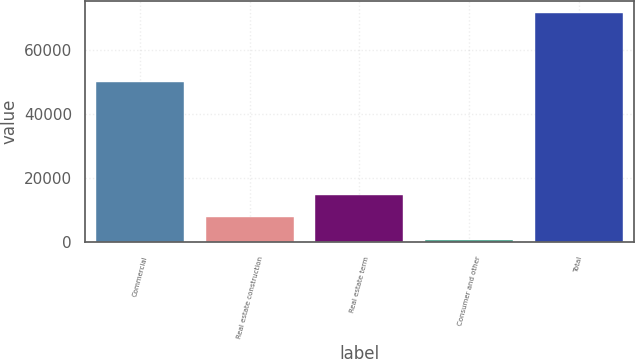Convert chart. <chart><loc_0><loc_0><loc_500><loc_500><bar_chart><fcel>Commercial<fcel>Real estate construction<fcel>Real estate term<fcel>Consumer and other<fcel>Total<nl><fcel>49985<fcel>7861.3<fcel>14965.6<fcel>757<fcel>71800<nl></chart> 